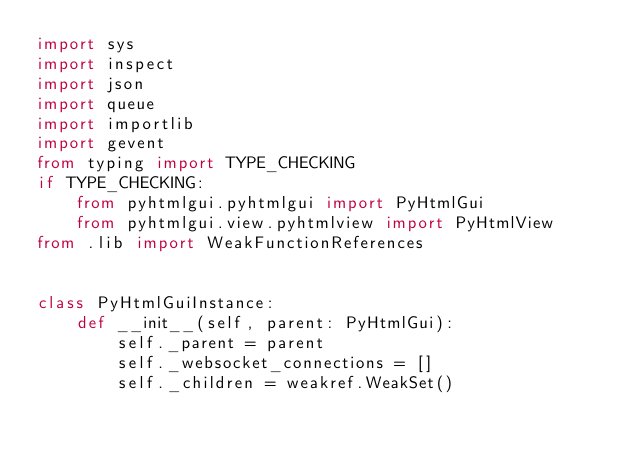<code> <loc_0><loc_0><loc_500><loc_500><_Python_>import sys
import inspect
import json
import queue
import importlib
import gevent
from typing import TYPE_CHECKING
if TYPE_CHECKING:
    from pyhtmlgui.pyhtmlgui import PyHtmlGui
    from pyhtmlgui.view.pyhtmlview import PyHtmlView
from .lib import WeakFunctionReferences


class PyHtmlGuiInstance:
    def __init__(self, parent: PyHtmlGui):
        self._parent = parent
        self._websocket_connections = []
        self._children = weakref.WeakSet()</code> 